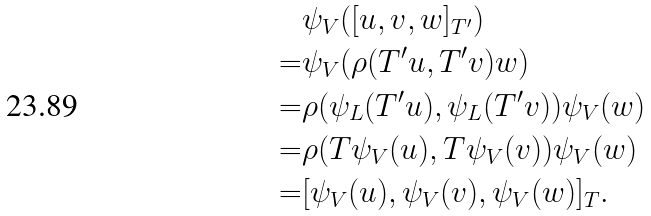Convert formula to latex. <formula><loc_0><loc_0><loc_500><loc_500>& \psi _ { V } ( [ u , v , w ] _ { T ^ { \prime } } ) \\ = & \psi _ { V } ( \rho ( T ^ { \prime } u , T ^ { \prime } v ) w ) \\ = & \rho ( \psi _ { L } ( T ^ { \prime } u ) , \psi _ { L } ( T ^ { \prime } v ) ) \psi _ { V } ( w ) \\ = & \rho ( T \psi _ { V } ( u ) , T \psi _ { V } ( v ) ) \psi _ { V } ( w ) \\ = & [ \psi _ { V } ( u ) , \psi _ { V } ( v ) , \psi _ { V } ( w ) ] _ { T } .</formula> 